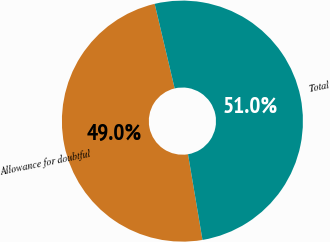Convert chart to OTSL. <chart><loc_0><loc_0><loc_500><loc_500><pie_chart><fcel>Allowance for doubtful<fcel>Total<nl><fcel>48.97%<fcel>51.03%<nl></chart> 